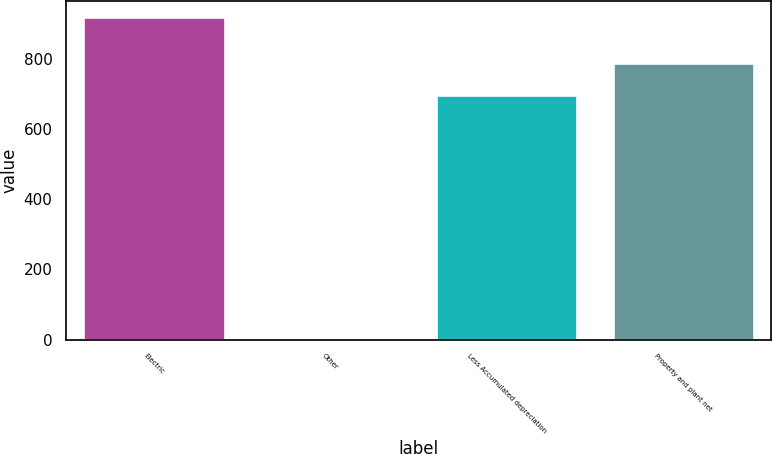Convert chart. <chart><loc_0><loc_0><loc_500><loc_500><bar_chart><fcel>Electric<fcel>Other<fcel>Less Accumulated depreciation<fcel>Property and plant net<nl><fcel>921<fcel>3<fcel>697<fcel>788.8<nl></chart> 